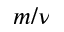Convert formula to latex. <formula><loc_0><loc_0><loc_500><loc_500>m / \nu</formula> 